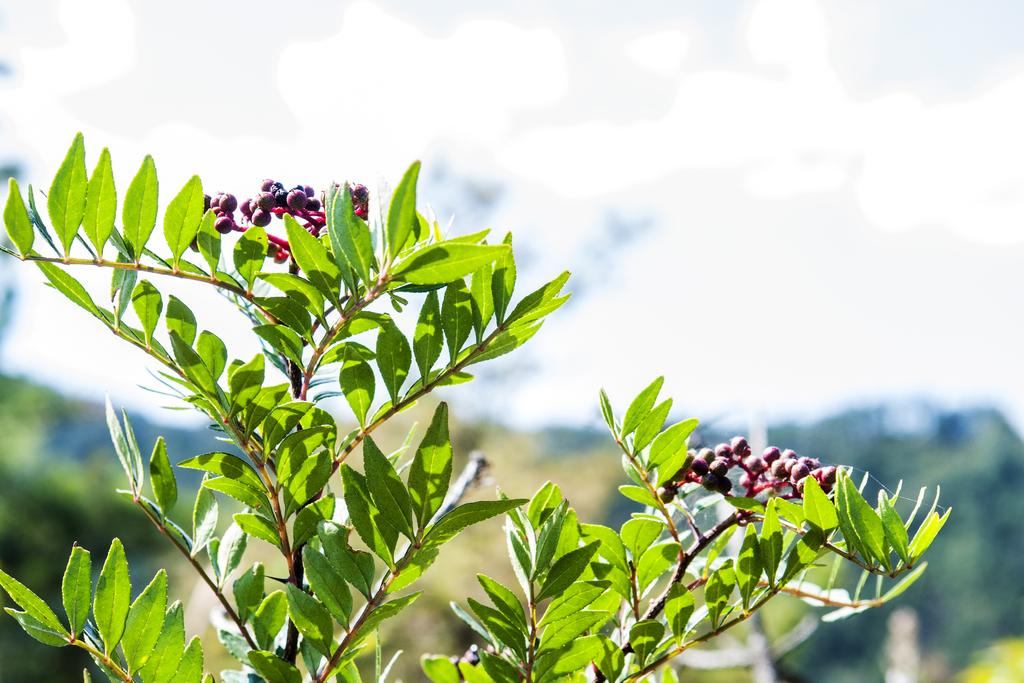What type of vegetation can be seen in the image? There are leaves in the image. What are the leaves attached to in the image? There are berries on the stem in the image. Can you describe the background of the image? The background of the image is blurred. What type of mitten is being used to pick the berries in the image? There is no mitten present in the image; it only shows leaves and berries on a stem. 